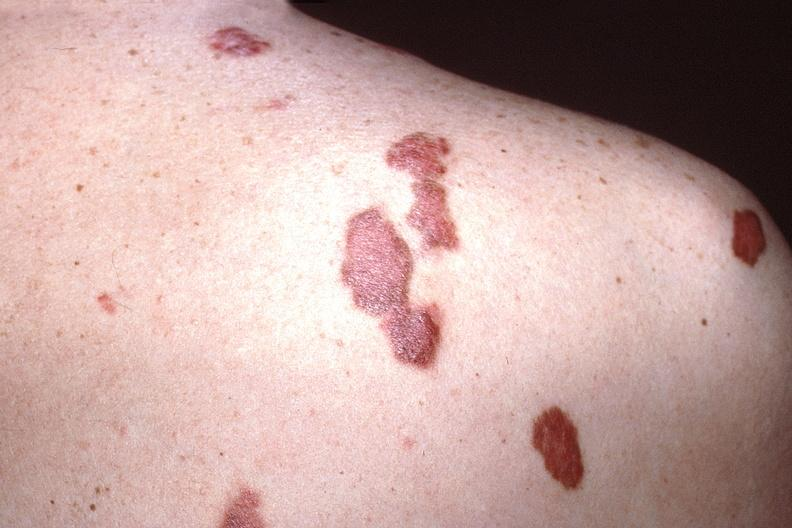where is this?
Answer the question using a single word or phrase. Skin 